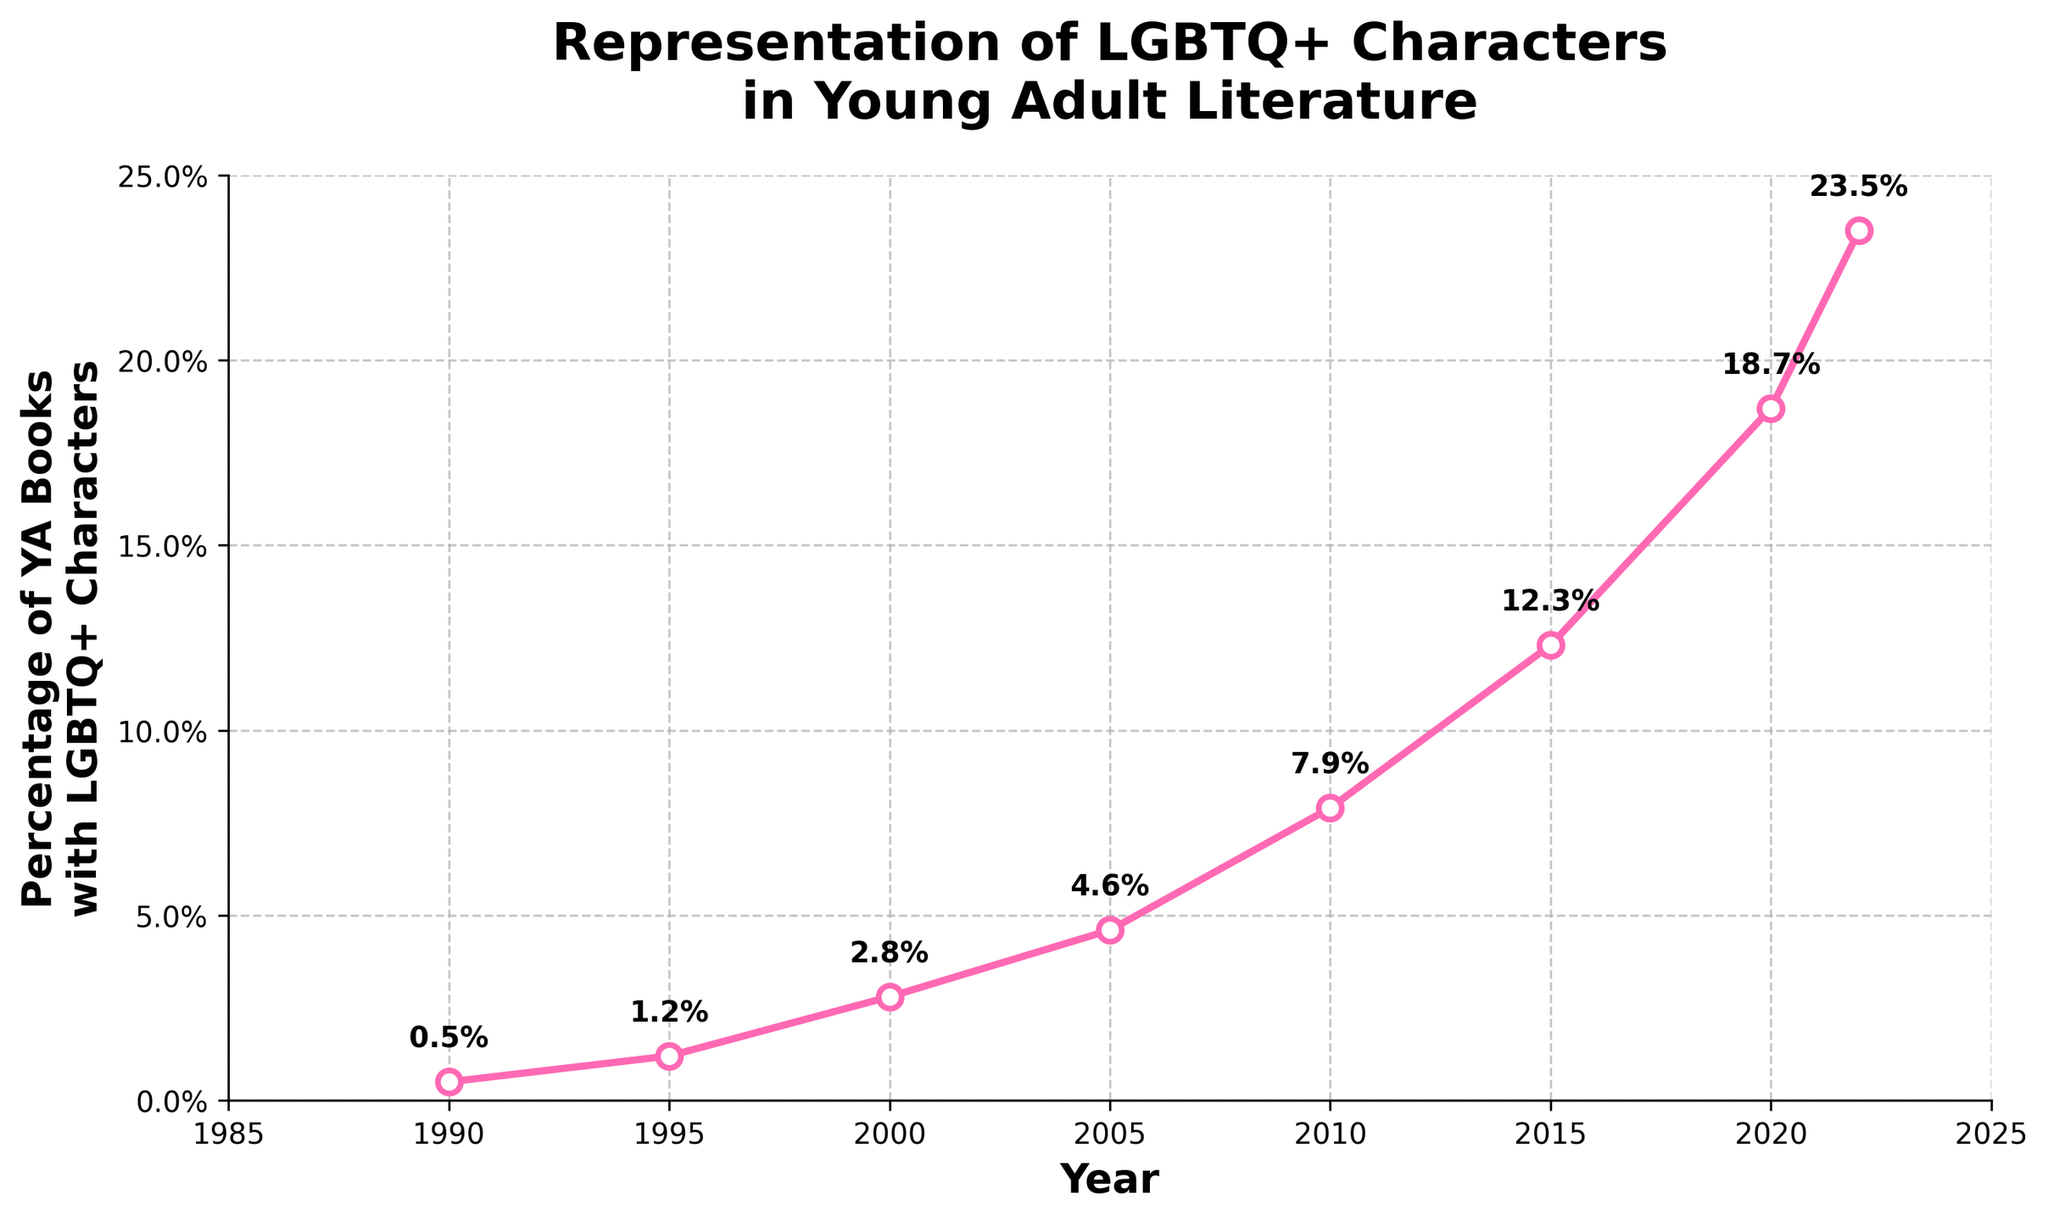How much did the percentage of YA books with LGBTQ+ characters increase from 1990 to 2022? To calculate this, subtract the percentage in 1990 from the percentage in 2022. This is 23.5% - 0.5% = 23%.
Answer: 23% In which year did the percentage of YA books with LGBTQ+ characters first exceed 10%? Identify the year in the chart where the percentage first crosses 10%. This occurs in 2015 with a percentage of 12.3%.
Answer: 2015 How many years did it take for the percentage of YA books with LGBTQ+ characters to increase from 4.6% to 18.7%? Find the years corresponding to 4.6% and 18.7% in the chart, which are 2005 and 2020, respectively. Subtract 2005 from 2020 to get the number of years. 2020 - 2005 = 15 years.
Answer: 15 years By how much did the percentage of YA books with LGBTQ+ characters change between 2000 and 2010? Subtract the percentage in 2000 from the percentage in 2010. This is 7.9% - 2.8% = 5.1%.
Answer: 5.1% Compare the percentage increase between the periods 1990-1995 and 2015-2020. Which period had a greater increase? Calculate the increase for each period. For 1990-1995: 1.2% - 0.5% = 0.7%. For 2015-2020: 18.7% - 12.3% = 6.4%. The period 2015-2020 had a greater increase.
Answer: 2015-2020 What was the average percentage of YA books with LGBTQ+ characters from 2010 to 2020? Add the percentages for 2010, 2015, and 2020, and then divide by 3. (7.9% + 12.3% + 18.7%) / 3 = 39% / 3 = 13%.
Answer: 13% Which decade experienced the highest cumulative increase in the percentage of YA books with LGBTQ+ characters? Evaluate the cumulative increase for each decade. 
1990-2000: 2.8% - 0.5% = 2.3%. 
2000-2010: 7.9% - 2.8% = 5.1%. 
2010-2020: 18.7% - 7.9% = 10.8%. 
The decade 2010-2020 had the highest cumulative increase of 10.8%.
Answer: 2010-2020 Between which consecutive pairs of years was the smallest increase in the percentage of YA books with LGBTQ+ characters observed? Compute the differences for each consecutive pair of years: 
1990-1995: 0.7%, 
1995-2000: 1.6%, 
2000-2005: 1.8%, 
2005-2010: 3.3%, 
2010-2015: 4.4%, 
2015-2020: 6.4%, 
2020-2022: 4.8%. 
The smallest increase observed is 0.7% between 1990 and 1995.
Answer: 1990-1995 What visual elements did the plot use to make the data easier to understand? The plot uses markers (circles) on data points, a pink line connecting the markers, white-filled markers with pink edges, and labeling of data points with percentages. It also includes gridlines and hides the top and right spines for clarity.
Answer: Markers, pink line, percentage labels, gridlines At what year does the y-axis start reaching beyond 10% for the percentage of YA books with LGBTQ+ characters? Look at the y-values and identify the first year where the percentage exceeds 10%. This occurs in 2015.
Answer: 2015 